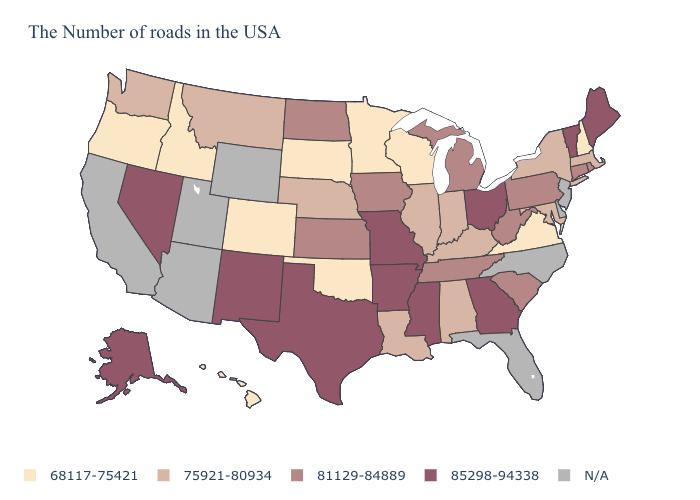What is the value of Iowa?
Short answer required. 81129-84889. What is the highest value in the USA?
Quick response, please. 85298-94338. Name the states that have a value in the range 68117-75421?
Concise answer only. New Hampshire, Virginia, Wisconsin, Minnesota, Oklahoma, South Dakota, Colorado, Idaho, Oregon, Hawaii. Among the states that border Ohio , which have the highest value?
Quick response, please. Pennsylvania, West Virginia, Michigan. Does Georgia have the highest value in the South?
Short answer required. Yes. Name the states that have a value in the range N/A?
Keep it brief. New Jersey, Delaware, North Carolina, Florida, Wyoming, Utah, Arizona, California. Does Colorado have the lowest value in the West?
Quick response, please. Yes. What is the value of Wisconsin?
Give a very brief answer. 68117-75421. Which states have the highest value in the USA?
Be succinct. Maine, Vermont, Ohio, Georgia, Mississippi, Missouri, Arkansas, Texas, New Mexico, Nevada, Alaska. Does New York have the highest value in the USA?
Give a very brief answer. No. What is the lowest value in the USA?
Answer briefly. 68117-75421. Name the states that have a value in the range 75921-80934?
Quick response, please. Massachusetts, New York, Maryland, Kentucky, Indiana, Alabama, Illinois, Louisiana, Nebraska, Montana, Washington. Among the states that border Iowa , does Minnesota have the lowest value?
Concise answer only. Yes. 